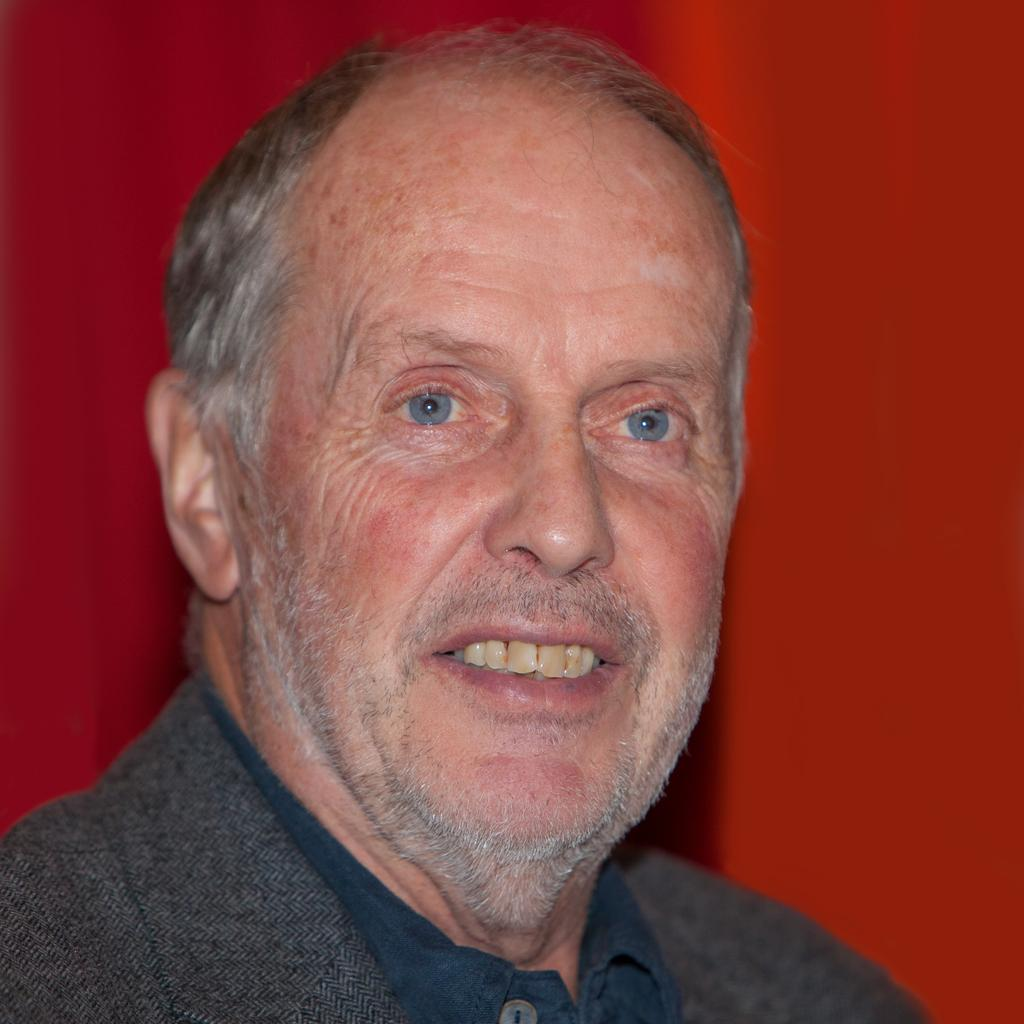What is present in the image? There is a person in the image. What can be observed about the person's attire? The person is wearing clothes. What color is the background of the image? The background of the image is red. What type of lumber is being used in the meeting depicted in the image? There is no meeting or lumber present in the image; it features a person with a red background. 